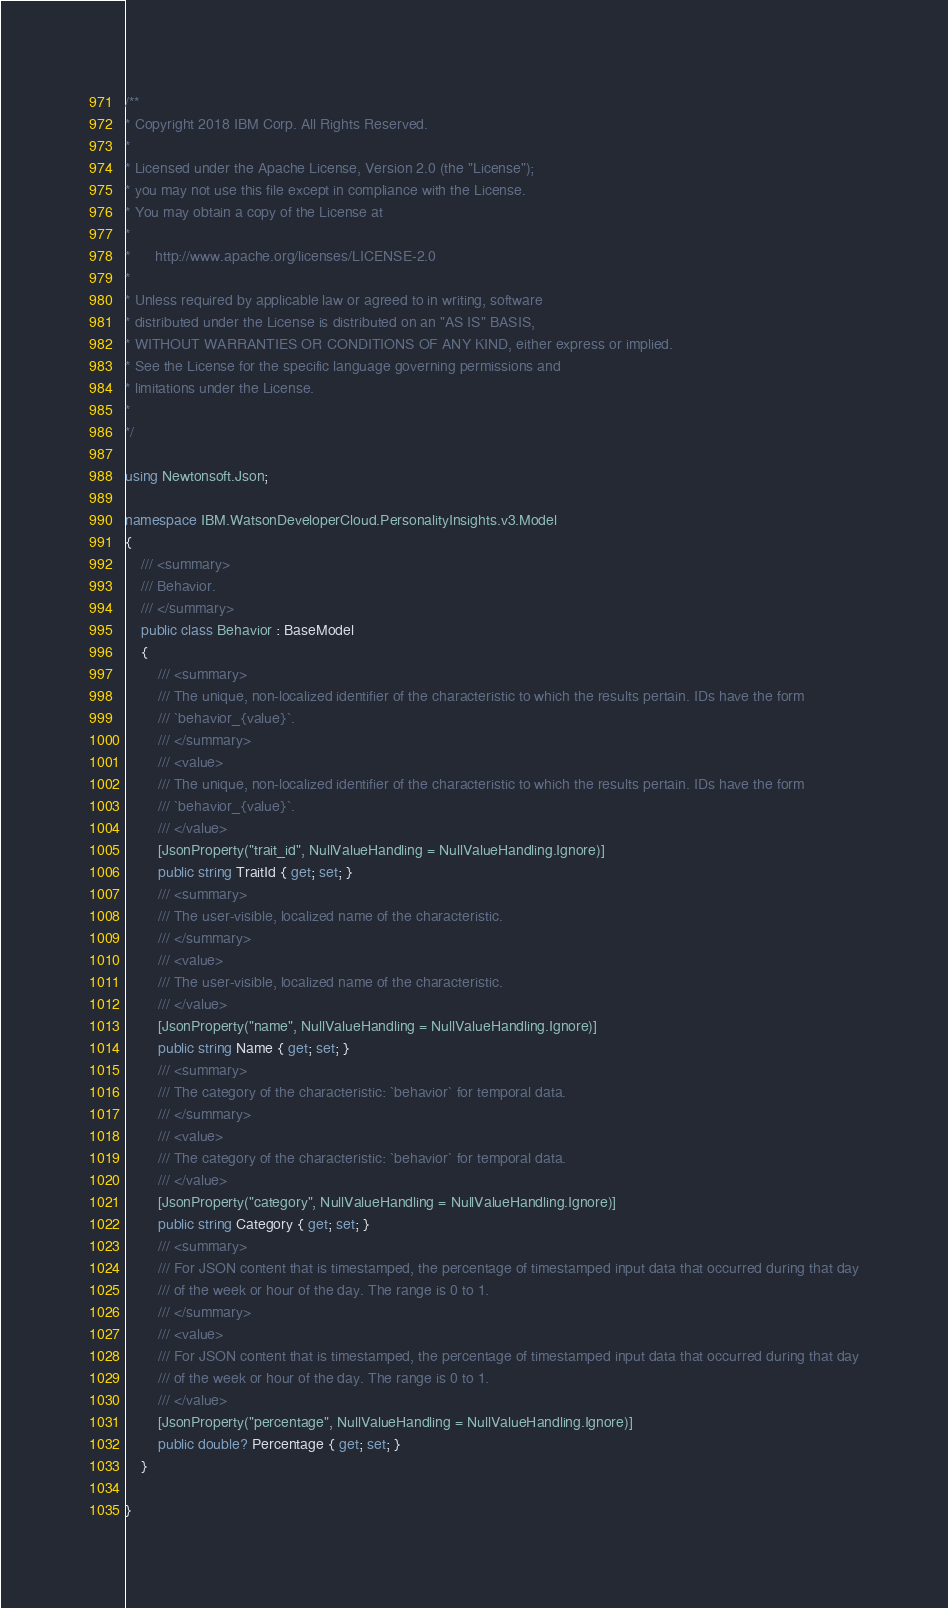Convert code to text. <code><loc_0><loc_0><loc_500><loc_500><_C#_>/**
* Copyright 2018 IBM Corp. All Rights Reserved.
*
* Licensed under the Apache License, Version 2.0 (the "License");
* you may not use this file except in compliance with the License.
* You may obtain a copy of the License at
*
*      http://www.apache.org/licenses/LICENSE-2.0
*
* Unless required by applicable law or agreed to in writing, software
* distributed under the License is distributed on an "AS IS" BASIS,
* WITHOUT WARRANTIES OR CONDITIONS OF ANY KIND, either express or implied.
* See the License for the specific language governing permissions and
* limitations under the License.
*
*/

using Newtonsoft.Json;

namespace IBM.WatsonDeveloperCloud.PersonalityInsights.v3.Model
{
    /// <summary>
    /// Behavior.
    /// </summary>
    public class Behavior : BaseModel
    {
        /// <summary>
        /// The unique, non-localized identifier of the characteristic to which the results pertain. IDs have the form
        /// `behavior_{value}`.
        /// </summary>
        /// <value>
        /// The unique, non-localized identifier of the characteristic to which the results pertain. IDs have the form
        /// `behavior_{value}`.
        /// </value>
        [JsonProperty("trait_id", NullValueHandling = NullValueHandling.Ignore)]
        public string TraitId { get; set; }
        /// <summary>
        /// The user-visible, localized name of the characteristic.
        /// </summary>
        /// <value>
        /// The user-visible, localized name of the characteristic.
        /// </value>
        [JsonProperty("name", NullValueHandling = NullValueHandling.Ignore)]
        public string Name { get; set; }
        /// <summary>
        /// The category of the characteristic: `behavior` for temporal data.
        /// </summary>
        /// <value>
        /// The category of the characteristic: `behavior` for temporal data.
        /// </value>
        [JsonProperty("category", NullValueHandling = NullValueHandling.Ignore)]
        public string Category { get; set; }
        /// <summary>
        /// For JSON content that is timestamped, the percentage of timestamped input data that occurred during that day
        /// of the week or hour of the day. The range is 0 to 1.
        /// </summary>
        /// <value>
        /// For JSON content that is timestamped, the percentage of timestamped input data that occurred during that day
        /// of the week or hour of the day. The range is 0 to 1.
        /// </value>
        [JsonProperty("percentage", NullValueHandling = NullValueHandling.Ignore)]
        public double? Percentage { get; set; }
    }

}
</code> 